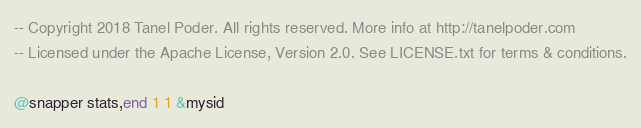Convert code to text. <code><loc_0><loc_0><loc_500><loc_500><_SQL_>-- Copyright 2018 Tanel Poder. All rights reserved. More info at http://tanelpoder.com
-- Licensed under the Apache License, Version 2.0. See LICENSE.txt for terms & conditions.

@snapper stats,end 1 1 &mysid
</code> 